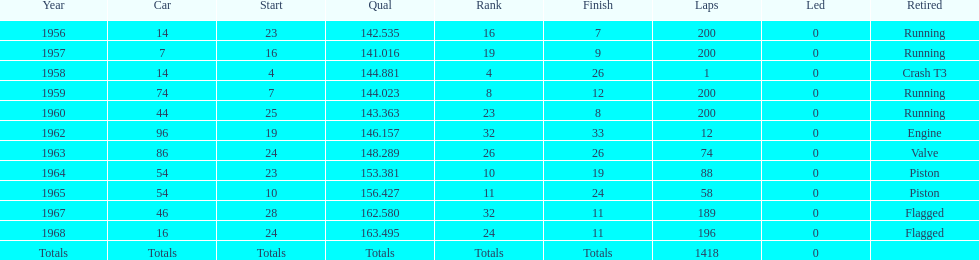What was its best starting position? 4. 